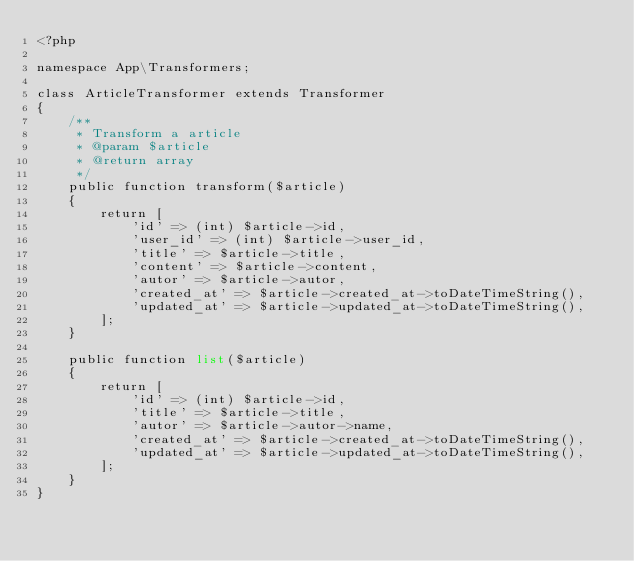Convert code to text. <code><loc_0><loc_0><loc_500><loc_500><_PHP_><?php

namespace App\Transformers;

class ArticleTransformer extends Transformer
{
    /**
     * Transform a article
     * @param $article
     * @return array
     */
    public function transform($article)
    {
        return [
            'id' => (int) $article->id,
            'user_id' => (int) $article->user_id,
            'title' => $article->title,
            'content' => $article->content,
            'autor' => $article->autor,
            'created_at' => $article->created_at->toDateTimeString(),
            'updated_at' => $article->updated_at->toDateTimeString(),
        ];
    }

    public function list($article)
    {
        return [
            'id' => (int) $article->id,
            'title' => $article->title,
            'autor' => $article->autor->name,
            'created_at' => $article->created_at->toDateTimeString(),
            'updated_at' => $article->updated_at->toDateTimeString(),
        ];
    }
}
</code> 